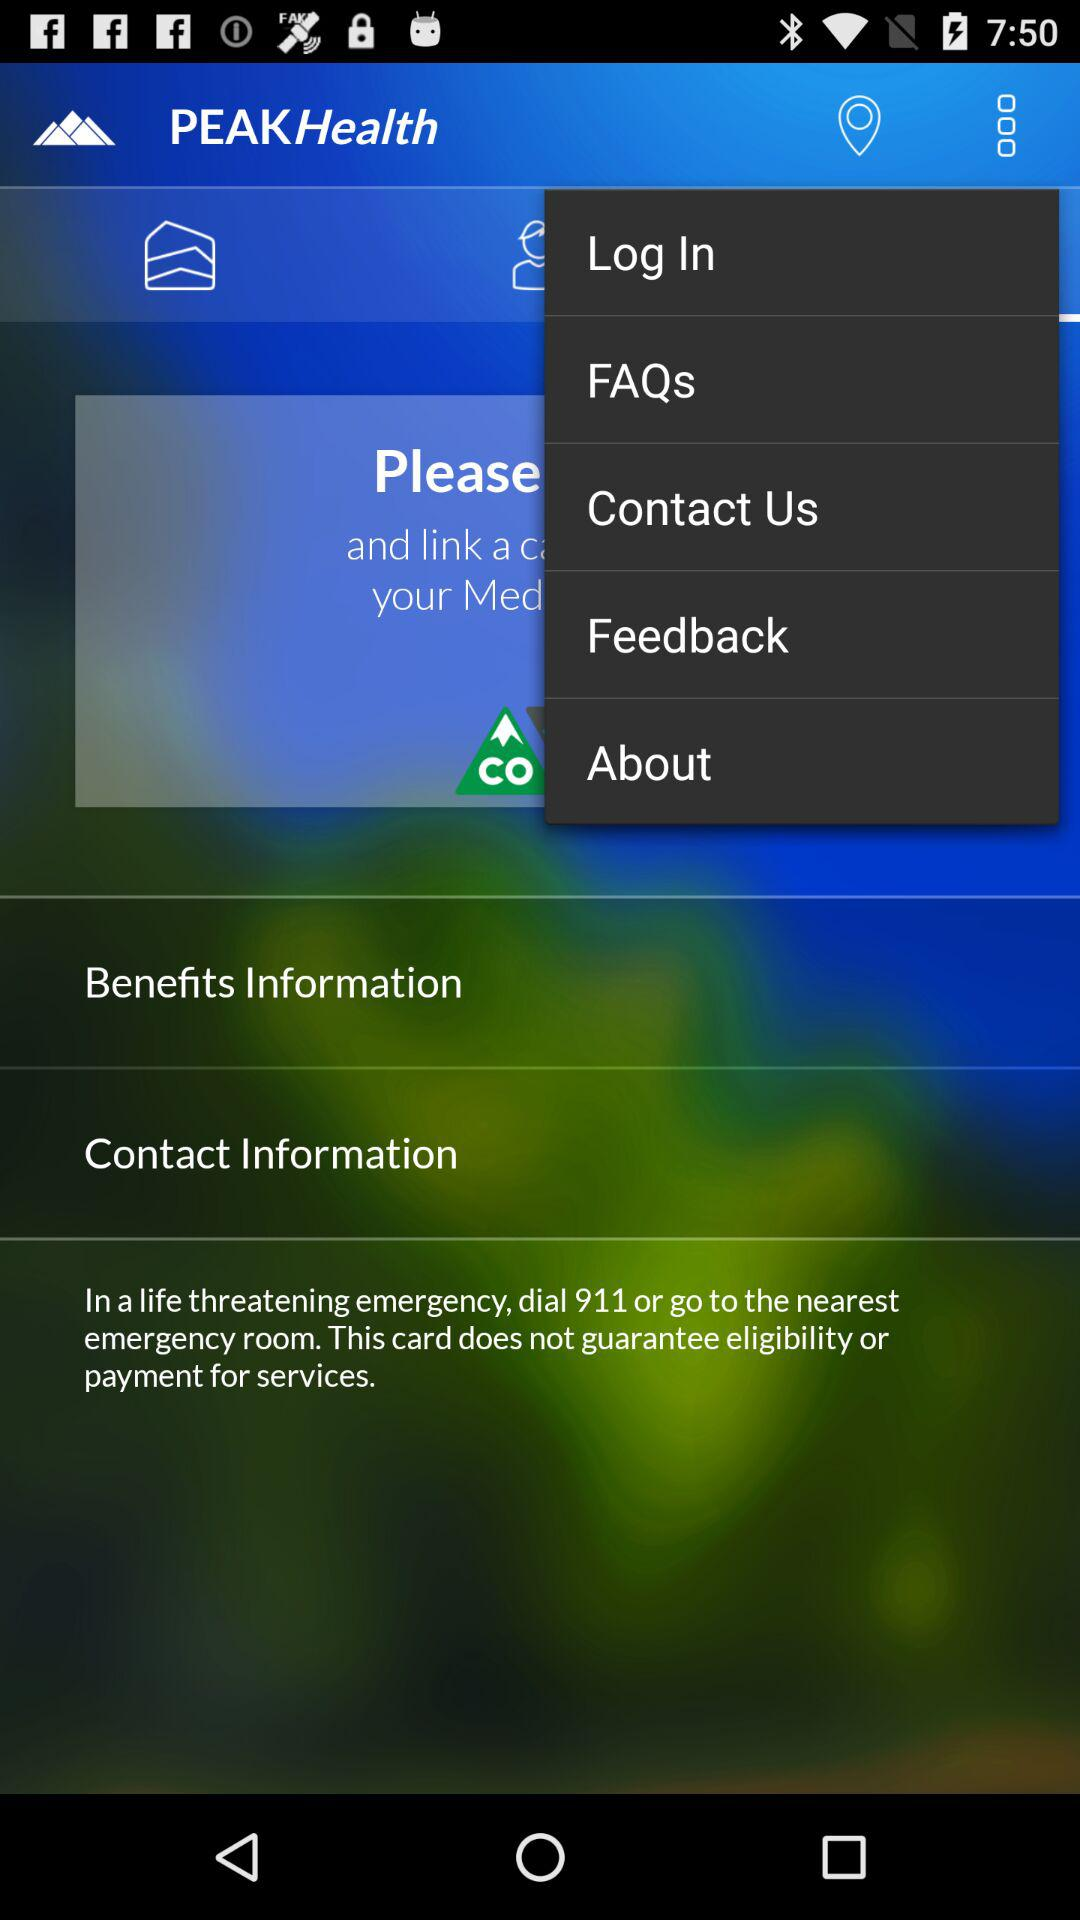What is the application name? The application name is "PEAKHealth". 